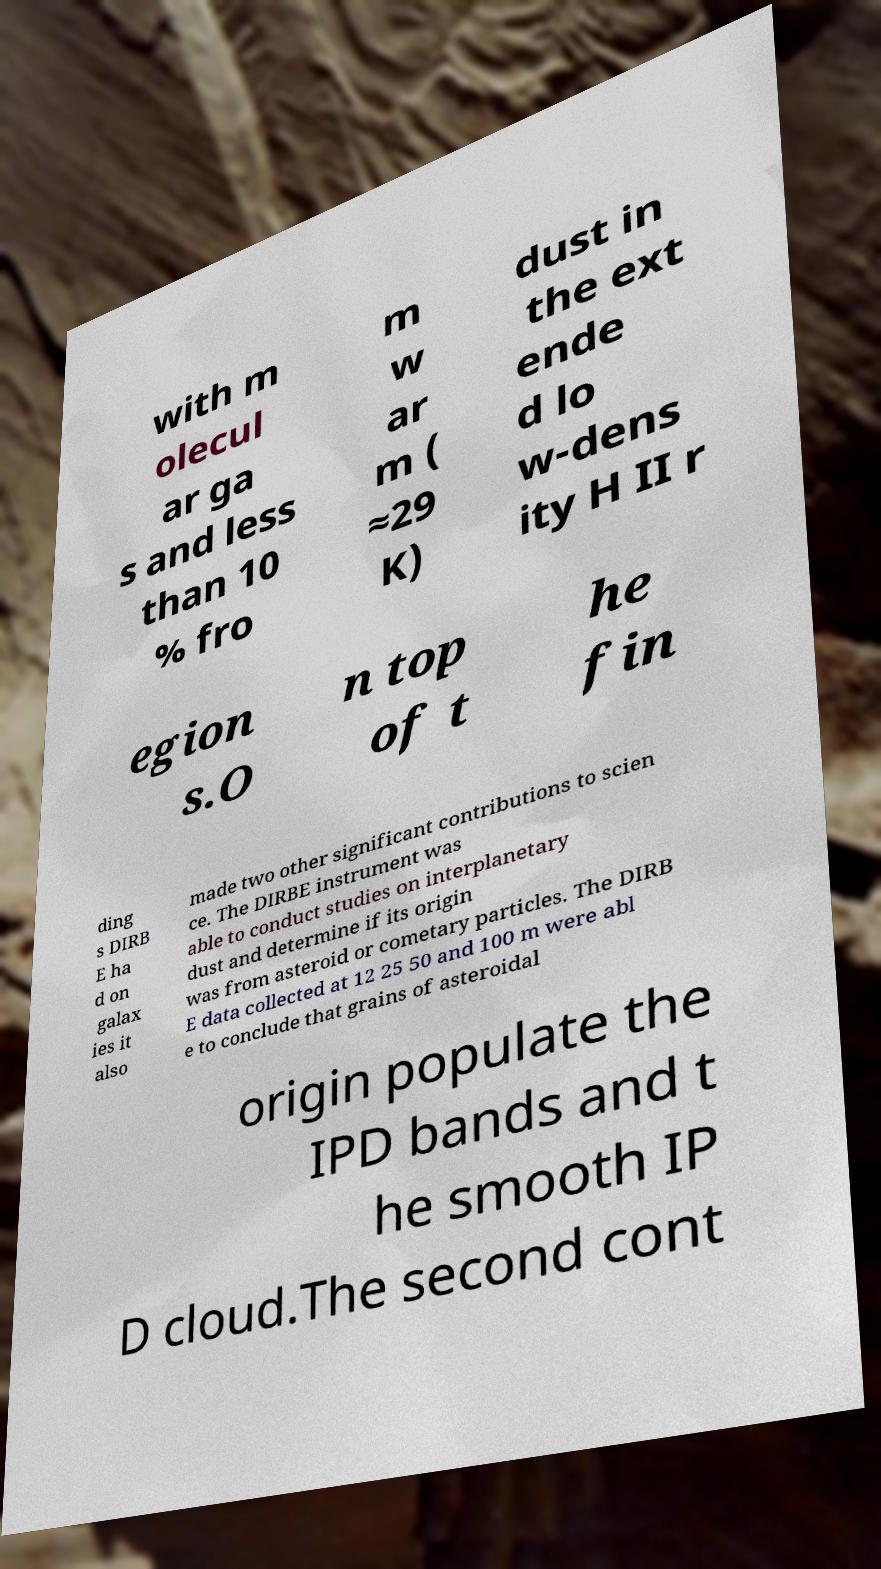Can you accurately transcribe the text from the provided image for me? with m olecul ar ga s and less than 10 % fro m w ar m ( ≈29 K) dust in the ext ende d lo w-dens ity H II r egion s.O n top of t he fin ding s DIRB E ha d on galax ies it also made two other significant contributions to scien ce. The DIRBE instrument was able to conduct studies on interplanetary dust and determine if its origin was from asteroid or cometary particles. The DIRB E data collected at 12 25 50 and 100 m were abl e to conclude that grains of asteroidal origin populate the IPD bands and t he smooth IP D cloud.The second cont 